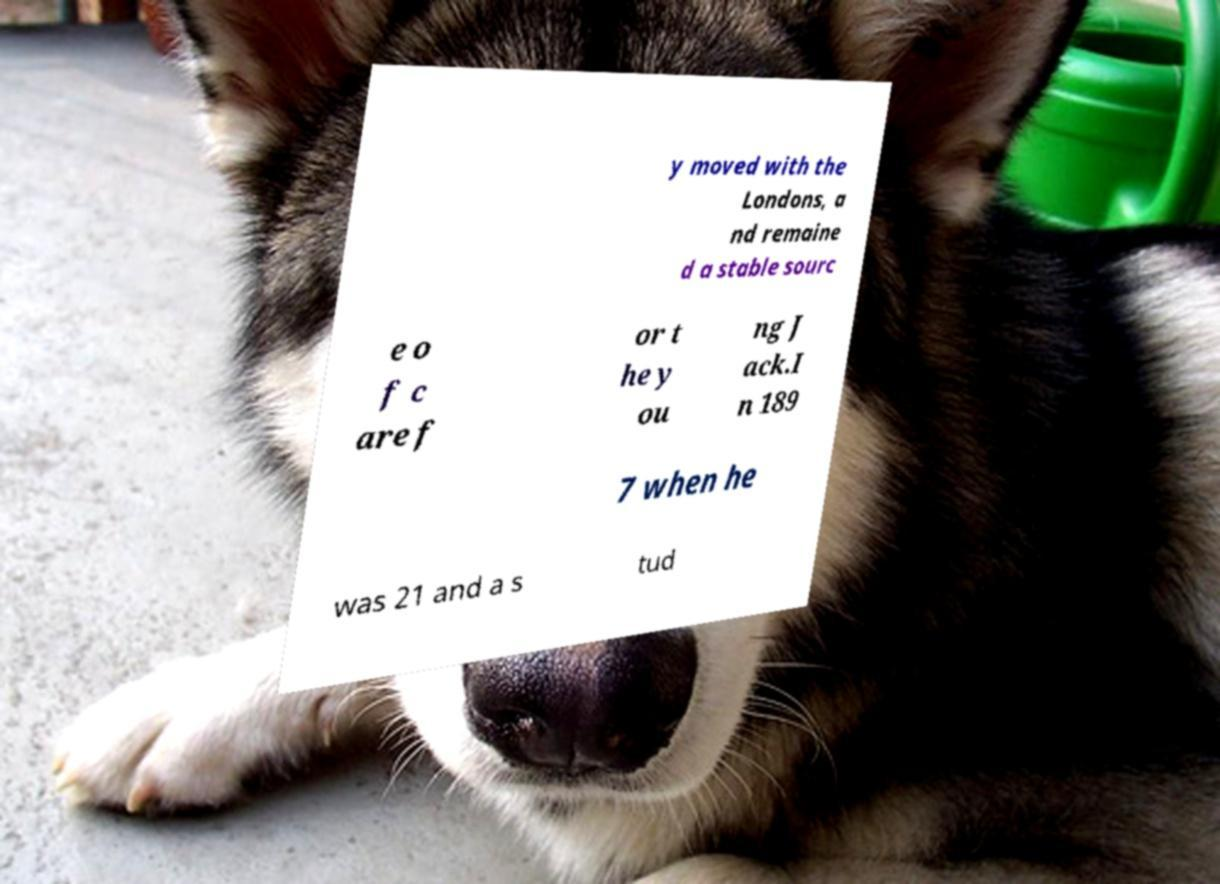There's text embedded in this image that I need extracted. Can you transcribe it verbatim? y moved with the Londons, a nd remaine d a stable sourc e o f c are f or t he y ou ng J ack.I n 189 7 when he was 21 and a s tud 